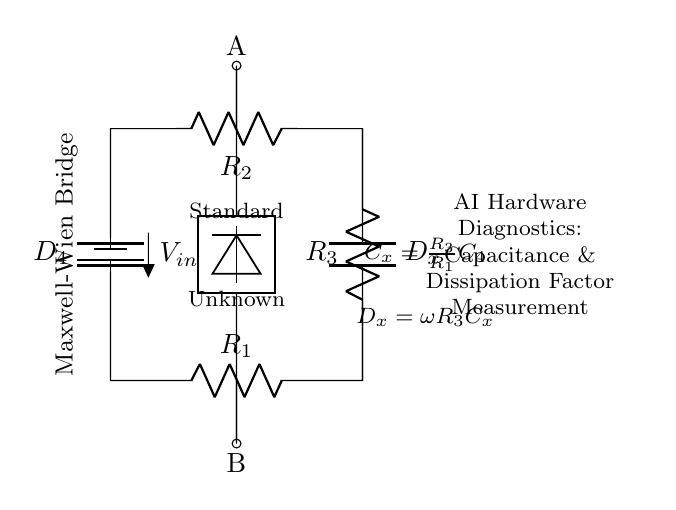What does C_x represent in the circuit? C_x represents the unknown capacitance being measured in the bridge circuit, which is connected in parallel with a known resistance R_3.
Answer: unknown capacitance What does D_x indicate? D_x indicates the dissipation factor of the capacitor C_x, defined as the product of the angular frequency and the resistance R_3 multiplied by C_x.
Answer: dissipation factor What are the two main types of components in the circuit? The two main types of components are resistors and capacitors, which form the bridge circuit.
Answer: resistors and capacitors What is the purpose of the detector in the circuit? The detector is used to measure the balance condition of the bridge, which indicates whether the capacitance is equal to a standard value.
Answer: measure balance What is the relationship given in the circuit for C_x? The circuit shows that the unknown capacitance C_x is equal to the ratio of R_3 to R_1 multiplied by C_4.
Answer: R_3 over R_1 times C_4 How does one achieve balance in a Maxwell-Wien bridge? Balance is achieved when the voltage across the detector is zero, which indicates that the ratios of resistances and capacitances match appropriately.
Answer: zero voltage across detector What is the orientation of the Maxwell-Wien bridge in the diagram? The orientation indicates the arrangement of resistors and capacitors in a rectangular format that allows for the measurement of the unknown capacitance.
Answer: rectangular format 